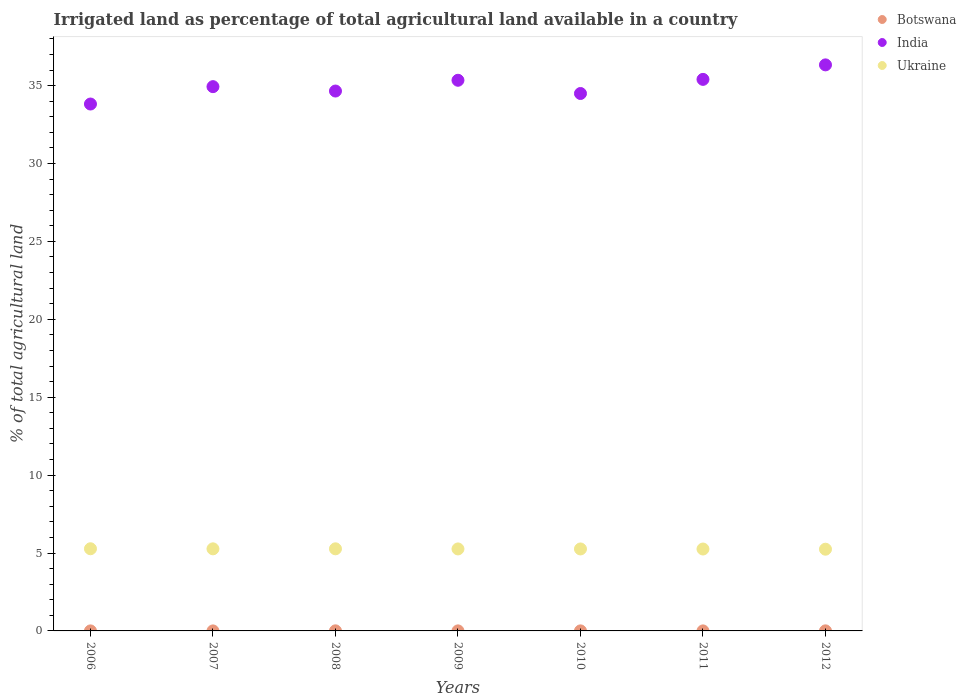How many different coloured dotlines are there?
Offer a terse response. 3. What is the percentage of irrigated land in Botswana in 2011?
Your answer should be compact. 0. Across all years, what is the maximum percentage of irrigated land in India?
Your answer should be compact. 36.33. Across all years, what is the minimum percentage of irrigated land in Ukraine?
Provide a short and direct response. 5.24. What is the total percentage of irrigated land in Botswana in the graph?
Your response must be concise. 0.02. What is the difference between the percentage of irrigated land in Botswana in 2008 and that in 2010?
Your response must be concise. 0. What is the difference between the percentage of irrigated land in Ukraine in 2006 and the percentage of irrigated land in Botswana in 2007?
Provide a succinct answer. 5.27. What is the average percentage of irrigated land in Botswana per year?
Offer a terse response. 0. In the year 2006, what is the difference between the percentage of irrigated land in Ukraine and percentage of irrigated land in Botswana?
Provide a short and direct response. 5.27. What is the ratio of the percentage of irrigated land in India in 2007 to that in 2008?
Offer a terse response. 1.01. Is the percentage of irrigated land in Botswana in 2006 less than that in 2008?
Make the answer very short. Yes. What is the difference between the highest and the second highest percentage of irrigated land in Ukraine?
Your response must be concise. 0. What is the difference between the highest and the lowest percentage of irrigated land in India?
Provide a succinct answer. 2.51. Is the sum of the percentage of irrigated land in Ukraine in 2008 and 2011 greater than the maximum percentage of irrigated land in Botswana across all years?
Give a very brief answer. Yes. Is it the case that in every year, the sum of the percentage of irrigated land in India and percentage of irrigated land in Botswana  is greater than the percentage of irrigated land in Ukraine?
Offer a terse response. Yes. Is the percentage of irrigated land in India strictly less than the percentage of irrigated land in Botswana over the years?
Offer a terse response. No. How many dotlines are there?
Provide a succinct answer. 3. What is the difference between two consecutive major ticks on the Y-axis?
Provide a short and direct response. 5. Are the values on the major ticks of Y-axis written in scientific E-notation?
Keep it short and to the point. No. Where does the legend appear in the graph?
Provide a succinct answer. Top right. How many legend labels are there?
Make the answer very short. 3. What is the title of the graph?
Provide a short and direct response. Irrigated land as percentage of total agricultural land available in a country. Does "Kenya" appear as one of the legend labels in the graph?
Provide a succinct answer. No. What is the label or title of the X-axis?
Provide a succinct answer. Years. What is the label or title of the Y-axis?
Ensure brevity in your answer.  % of total agricultural land. What is the % of total agricultural land of Botswana in 2006?
Your answer should be very brief. 0. What is the % of total agricultural land in India in 2006?
Keep it short and to the point. 33.82. What is the % of total agricultural land of Ukraine in 2006?
Ensure brevity in your answer.  5.27. What is the % of total agricultural land in Botswana in 2007?
Give a very brief answer. 0. What is the % of total agricultural land in India in 2007?
Offer a terse response. 34.93. What is the % of total agricultural land of Ukraine in 2007?
Provide a succinct answer. 5.27. What is the % of total agricultural land in Botswana in 2008?
Keep it short and to the point. 0.01. What is the % of total agricultural land in India in 2008?
Make the answer very short. 34.65. What is the % of total agricultural land of Ukraine in 2008?
Give a very brief answer. 5.27. What is the % of total agricultural land of Botswana in 2009?
Offer a terse response. 0. What is the % of total agricultural land in India in 2009?
Give a very brief answer. 35.34. What is the % of total agricultural land of Ukraine in 2009?
Your response must be concise. 5.26. What is the % of total agricultural land in Botswana in 2010?
Your response must be concise. 0. What is the % of total agricultural land of India in 2010?
Make the answer very short. 34.49. What is the % of total agricultural land of Ukraine in 2010?
Your answer should be compact. 5.26. What is the % of total agricultural land of Botswana in 2011?
Give a very brief answer. 0. What is the % of total agricultural land of India in 2011?
Offer a very short reply. 35.4. What is the % of total agricultural land of Ukraine in 2011?
Offer a very short reply. 5.26. What is the % of total agricultural land of Botswana in 2012?
Give a very brief answer. 0. What is the % of total agricultural land of India in 2012?
Provide a short and direct response. 36.33. What is the % of total agricultural land in Ukraine in 2012?
Keep it short and to the point. 5.24. Across all years, what is the maximum % of total agricultural land in Botswana?
Offer a terse response. 0.01. Across all years, what is the maximum % of total agricultural land in India?
Offer a very short reply. 36.33. Across all years, what is the maximum % of total agricultural land in Ukraine?
Make the answer very short. 5.27. Across all years, what is the minimum % of total agricultural land of Botswana?
Keep it short and to the point. 0. Across all years, what is the minimum % of total agricultural land in India?
Offer a terse response. 33.82. Across all years, what is the minimum % of total agricultural land of Ukraine?
Provide a short and direct response. 5.24. What is the total % of total agricultural land of Botswana in the graph?
Offer a terse response. 0.02. What is the total % of total agricultural land of India in the graph?
Offer a very short reply. 244.96. What is the total % of total agricultural land in Ukraine in the graph?
Your answer should be very brief. 36.84. What is the difference between the % of total agricultural land in Botswana in 2006 and that in 2007?
Ensure brevity in your answer.  0. What is the difference between the % of total agricultural land of India in 2006 and that in 2007?
Provide a short and direct response. -1.12. What is the difference between the % of total agricultural land of Ukraine in 2006 and that in 2007?
Provide a short and direct response. 0.01. What is the difference between the % of total agricultural land of Botswana in 2006 and that in 2008?
Your answer should be compact. -0. What is the difference between the % of total agricultural land in India in 2006 and that in 2008?
Ensure brevity in your answer.  -0.83. What is the difference between the % of total agricultural land of Ukraine in 2006 and that in 2008?
Your answer should be very brief. 0. What is the difference between the % of total agricultural land in Botswana in 2006 and that in 2009?
Give a very brief answer. -0. What is the difference between the % of total agricultural land in India in 2006 and that in 2009?
Keep it short and to the point. -1.53. What is the difference between the % of total agricultural land in Ukraine in 2006 and that in 2009?
Ensure brevity in your answer.  0.01. What is the difference between the % of total agricultural land in Botswana in 2006 and that in 2010?
Your response must be concise. -0. What is the difference between the % of total agricultural land in India in 2006 and that in 2010?
Offer a terse response. -0.68. What is the difference between the % of total agricultural land in Ukraine in 2006 and that in 2010?
Keep it short and to the point. 0.01. What is the difference between the % of total agricultural land in Botswana in 2006 and that in 2011?
Ensure brevity in your answer.  -0. What is the difference between the % of total agricultural land of India in 2006 and that in 2011?
Ensure brevity in your answer.  -1.58. What is the difference between the % of total agricultural land of Ukraine in 2006 and that in 2011?
Offer a very short reply. 0.02. What is the difference between the % of total agricultural land in Botswana in 2006 and that in 2012?
Your answer should be compact. -0. What is the difference between the % of total agricultural land of India in 2006 and that in 2012?
Offer a very short reply. -2.51. What is the difference between the % of total agricultural land in Ukraine in 2006 and that in 2012?
Offer a very short reply. 0.03. What is the difference between the % of total agricultural land of Botswana in 2007 and that in 2008?
Give a very brief answer. -0.01. What is the difference between the % of total agricultural land of India in 2007 and that in 2008?
Give a very brief answer. 0.28. What is the difference between the % of total agricultural land of Ukraine in 2007 and that in 2008?
Your answer should be compact. -0. What is the difference between the % of total agricultural land of Botswana in 2007 and that in 2009?
Your answer should be compact. -0. What is the difference between the % of total agricultural land in India in 2007 and that in 2009?
Keep it short and to the point. -0.41. What is the difference between the % of total agricultural land of Ukraine in 2007 and that in 2009?
Your answer should be very brief. 0.01. What is the difference between the % of total agricultural land of Botswana in 2007 and that in 2010?
Give a very brief answer. -0. What is the difference between the % of total agricultural land of India in 2007 and that in 2010?
Your response must be concise. 0.44. What is the difference between the % of total agricultural land in Ukraine in 2007 and that in 2010?
Give a very brief answer. 0.01. What is the difference between the % of total agricultural land in Botswana in 2007 and that in 2011?
Your answer should be compact. -0. What is the difference between the % of total agricultural land of India in 2007 and that in 2011?
Offer a terse response. -0.47. What is the difference between the % of total agricultural land of Ukraine in 2007 and that in 2011?
Keep it short and to the point. 0.01. What is the difference between the % of total agricultural land of Botswana in 2007 and that in 2012?
Ensure brevity in your answer.  -0. What is the difference between the % of total agricultural land in India in 2007 and that in 2012?
Ensure brevity in your answer.  -1.4. What is the difference between the % of total agricultural land in Ukraine in 2007 and that in 2012?
Make the answer very short. 0.02. What is the difference between the % of total agricultural land of Botswana in 2008 and that in 2009?
Offer a very short reply. 0. What is the difference between the % of total agricultural land in India in 2008 and that in 2009?
Your response must be concise. -0.69. What is the difference between the % of total agricultural land in Ukraine in 2008 and that in 2009?
Give a very brief answer. 0.01. What is the difference between the % of total agricultural land in Botswana in 2008 and that in 2010?
Offer a very short reply. 0. What is the difference between the % of total agricultural land of India in 2008 and that in 2010?
Your answer should be compact. 0.16. What is the difference between the % of total agricultural land in Ukraine in 2008 and that in 2010?
Provide a succinct answer. 0.01. What is the difference between the % of total agricultural land in Botswana in 2008 and that in 2011?
Your answer should be compact. 0. What is the difference between the % of total agricultural land in India in 2008 and that in 2011?
Make the answer very short. -0.75. What is the difference between the % of total agricultural land in Ukraine in 2008 and that in 2011?
Make the answer very short. 0.01. What is the difference between the % of total agricultural land in Botswana in 2008 and that in 2012?
Keep it short and to the point. 0. What is the difference between the % of total agricultural land in India in 2008 and that in 2012?
Offer a very short reply. -1.68. What is the difference between the % of total agricultural land of Ukraine in 2008 and that in 2012?
Your answer should be compact. 0.02. What is the difference between the % of total agricultural land of Botswana in 2009 and that in 2010?
Make the answer very short. -0. What is the difference between the % of total agricultural land of India in 2009 and that in 2010?
Your answer should be very brief. 0.85. What is the difference between the % of total agricultural land in Ukraine in 2009 and that in 2010?
Provide a succinct answer. 0. What is the difference between the % of total agricultural land in Botswana in 2009 and that in 2011?
Your response must be concise. 0. What is the difference between the % of total agricultural land in India in 2009 and that in 2011?
Offer a very short reply. -0.06. What is the difference between the % of total agricultural land of Ukraine in 2009 and that in 2011?
Your response must be concise. 0.01. What is the difference between the % of total agricultural land of Botswana in 2009 and that in 2012?
Ensure brevity in your answer.  -0. What is the difference between the % of total agricultural land of India in 2009 and that in 2012?
Give a very brief answer. -0.99. What is the difference between the % of total agricultural land of Ukraine in 2009 and that in 2012?
Make the answer very short. 0.02. What is the difference between the % of total agricultural land of Botswana in 2010 and that in 2011?
Offer a very short reply. 0. What is the difference between the % of total agricultural land of India in 2010 and that in 2011?
Your answer should be very brief. -0.91. What is the difference between the % of total agricultural land in Ukraine in 2010 and that in 2011?
Offer a very short reply. 0. What is the difference between the % of total agricultural land in Botswana in 2010 and that in 2012?
Offer a terse response. -0. What is the difference between the % of total agricultural land in India in 2010 and that in 2012?
Your response must be concise. -1.84. What is the difference between the % of total agricultural land in Ukraine in 2010 and that in 2012?
Keep it short and to the point. 0.02. What is the difference between the % of total agricultural land in Botswana in 2011 and that in 2012?
Your response must be concise. -0. What is the difference between the % of total agricultural land in India in 2011 and that in 2012?
Offer a terse response. -0.93. What is the difference between the % of total agricultural land in Ukraine in 2011 and that in 2012?
Offer a terse response. 0.01. What is the difference between the % of total agricultural land in Botswana in 2006 and the % of total agricultural land in India in 2007?
Ensure brevity in your answer.  -34.93. What is the difference between the % of total agricultural land in Botswana in 2006 and the % of total agricultural land in Ukraine in 2007?
Ensure brevity in your answer.  -5.27. What is the difference between the % of total agricultural land in India in 2006 and the % of total agricultural land in Ukraine in 2007?
Offer a very short reply. 28.55. What is the difference between the % of total agricultural land in Botswana in 2006 and the % of total agricultural land in India in 2008?
Your answer should be very brief. -34.65. What is the difference between the % of total agricultural land of Botswana in 2006 and the % of total agricultural land of Ukraine in 2008?
Ensure brevity in your answer.  -5.27. What is the difference between the % of total agricultural land of India in 2006 and the % of total agricultural land of Ukraine in 2008?
Your response must be concise. 28.55. What is the difference between the % of total agricultural land in Botswana in 2006 and the % of total agricultural land in India in 2009?
Your answer should be very brief. -35.34. What is the difference between the % of total agricultural land of Botswana in 2006 and the % of total agricultural land of Ukraine in 2009?
Give a very brief answer. -5.26. What is the difference between the % of total agricultural land in India in 2006 and the % of total agricultural land in Ukraine in 2009?
Give a very brief answer. 28.55. What is the difference between the % of total agricultural land in Botswana in 2006 and the % of total agricultural land in India in 2010?
Give a very brief answer. -34.49. What is the difference between the % of total agricultural land in Botswana in 2006 and the % of total agricultural land in Ukraine in 2010?
Your response must be concise. -5.26. What is the difference between the % of total agricultural land in India in 2006 and the % of total agricultural land in Ukraine in 2010?
Your answer should be very brief. 28.56. What is the difference between the % of total agricultural land in Botswana in 2006 and the % of total agricultural land in India in 2011?
Offer a very short reply. -35.4. What is the difference between the % of total agricultural land in Botswana in 2006 and the % of total agricultural land in Ukraine in 2011?
Make the answer very short. -5.26. What is the difference between the % of total agricultural land in India in 2006 and the % of total agricultural land in Ukraine in 2011?
Offer a very short reply. 28.56. What is the difference between the % of total agricultural land in Botswana in 2006 and the % of total agricultural land in India in 2012?
Your answer should be compact. -36.33. What is the difference between the % of total agricultural land in Botswana in 2006 and the % of total agricultural land in Ukraine in 2012?
Your response must be concise. -5.24. What is the difference between the % of total agricultural land of India in 2006 and the % of total agricultural land of Ukraine in 2012?
Offer a very short reply. 28.57. What is the difference between the % of total agricultural land in Botswana in 2007 and the % of total agricultural land in India in 2008?
Provide a succinct answer. -34.65. What is the difference between the % of total agricultural land of Botswana in 2007 and the % of total agricultural land of Ukraine in 2008?
Keep it short and to the point. -5.27. What is the difference between the % of total agricultural land of India in 2007 and the % of total agricultural land of Ukraine in 2008?
Provide a short and direct response. 29.66. What is the difference between the % of total agricultural land of Botswana in 2007 and the % of total agricultural land of India in 2009?
Provide a succinct answer. -35.34. What is the difference between the % of total agricultural land in Botswana in 2007 and the % of total agricultural land in Ukraine in 2009?
Offer a very short reply. -5.26. What is the difference between the % of total agricultural land in India in 2007 and the % of total agricultural land in Ukraine in 2009?
Make the answer very short. 29.67. What is the difference between the % of total agricultural land of Botswana in 2007 and the % of total agricultural land of India in 2010?
Your answer should be compact. -34.49. What is the difference between the % of total agricultural land of Botswana in 2007 and the % of total agricultural land of Ukraine in 2010?
Offer a terse response. -5.26. What is the difference between the % of total agricultural land in India in 2007 and the % of total agricultural land in Ukraine in 2010?
Your answer should be very brief. 29.67. What is the difference between the % of total agricultural land of Botswana in 2007 and the % of total agricultural land of India in 2011?
Offer a terse response. -35.4. What is the difference between the % of total agricultural land of Botswana in 2007 and the % of total agricultural land of Ukraine in 2011?
Your answer should be compact. -5.26. What is the difference between the % of total agricultural land of India in 2007 and the % of total agricultural land of Ukraine in 2011?
Your answer should be compact. 29.68. What is the difference between the % of total agricultural land of Botswana in 2007 and the % of total agricultural land of India in 2012?
Ensure brevity in your answer.  -36.33. What is the difference between the % of total agricultural land in Botswana in 2007 and the % of total agricultural land in Ukraine in 2012?
Keep it short and to the point. -5.24. What is the difference between the % of total agricultural land of India in 2007 and the % of total agricultural land of Ukraine in 2012?
Your answer should be very brief. 29.69. What is the difference between the % of total agricultural land in Botswana in 2008 and the % of total agricultural land in India in 2009?
Make the answer very short. -35.34. What is the difference between the % of total agricultural land of Botswana in 2008 and the % of total agricultural land of Ukraine in 2009?
Provide a short and direct response. -5.26. What is the difference between the % of total agricultural land in India in 2008 and the % of total agricultural land in Ukraine in 2009?
Make the answer very short. 29.39. What is the difference between the % of total agricultural land of Botswana in 2008 and the % of total agricultural land of India in 2010?
Provide a short and direct response. -34.49. What is the difference between the % of total agricultural land of Botswana in 2008 and the % of total agricultural land of Ukraine in 2010?
Offer a very short reply. -5.26. What is the difference between the % of total agricultural land of India in 2008 and the % of total agricultural land of Ukraine in 2010?
Ensure brevity in your answer.  29.39. What is the difference between the % of total agricultural land of Botswana in 2008 and the % of total agricultural land of India in 2011?
Make the answer very short. -35.39. What is the difference between the % of total agricultural land of Botswana in 2008 and the % of total agricultural land of Ukraine in 2011?
Ensure brevity in your answer.  -5.25. What is the difference between the % of total agricultural land of India in 2008 and the % of total agricultural land of Ukraine in 2011?
Provide a succinct answer. 29.39. What is the difference between the % of total agricultural land of Botswana in 2008 and the % of total agricultural land of India in 2012?
Provide a short and direct response. -36.32. What is the difference between the % of total agricultural land in Botswana in 2008 and the % of total agricultural land in Ukraine in 2012?
Provide a short and direct response. -5.24. What is the difference between the % of total agricultural land in India in 2008 and the % of total agricultural land in Ukraine in 2012?
Your answer should be very brief. 29.41. What is the difference between the % of total agricultural land of Botswana in 2009 and the % of total agricultural land of India in 2010?
Your response must be concise. -34.49. What is the difference between the % of total agricultural land of Botswana in 2009 and the % of total agricultural land of Ukraine in 2010?
Your answer should be compact. -5.26. What is the difference between the % of total agricultural land in India in 2009 and the % of total agricultural land in Ukraine in 2010?
Give a very brief answer. 30.08. What is the difference between the % of total agricultural land of Botswana in 2009 and the % of total agricultural land of India in 2011?
Provide a succinct answer. -35.4. What is the difference between the % of total agricultural land of Botswana in 2009 and the % of total agricultural land of Ukraine in 2011?
Give a very brief answer. -5.25. What is the difference between the % of total agricultural land in India in 2009 and the % of total agricultural land in Ukraine in 2011?
Your answer should be compact. 30.09. What is the difference between the % of total agricultural land of Botswana in 2009 and the % of total agricultural land of India in 2012?
Provide a succinct answer. -36.33. What is the difference between the % of total agricultural land of Botswana in 2009 and the % of total agricultural land of Ukraine in 2012?
Keep it short and to the point. -5.24. What is the difference between the % of total agricultural land in India in 2009 and the % of total agricultural land in Ukraine in 2012?
Your answer should be compact. 30.1. What is the difference between the % of total agricultural land in Botswana in 2010 and the % of total agricultural land in India in 2011?
Your answer should be compact. -35.4. What is the difference between the % of total agricultural land of Botswana in 2010 and the % of total agricultural land of Ukraine in 2011?
Give a very brief answer. -5.25. What is the difference between the % of total agricultural land of India in 2010 and the % of total agricultural land of Ukraine in 2011?
Keep it short and to the point. 29.24. What is the difference between the % of total agricultural land of Botswana in 2010 and the % of total agricultural land of India in 2012?
Make the answer very short. -36.33. What is the difference between the % of total agricultural land of Botswana in 2010 and the % of total agricultural land of Ukraine in 2012?
Offer a very short reply. -5.24. What is the difference between the % of total agricultural land of India in 2010 and the % of total agricultural land of Ukraine in 2012?
Your response must be concise. 29.25. What is the difference between the % of total agricultural land in Botswana in 2011 and the % of total agricultural land in India in 2012?
Your answer should be very brief. -36.33. What is the difference between the % of total agricultural land in Botswana in 2011 and the % of total agricultural land in Ukraine in 2012?
Ensure brevity in your answer.  -5.24. What is the difference between the % of total agricultural land in India in 2011 and the % of total agricultural land in Ukraine in 2012?
Your answer should be very brief. 30.15. What is the average % of total agricultural land in Botswana per year?
Make the answer very short. 0. What is the average % of total agricultural land in India per year?
Your answer should be very brief. 34.99. What is the average % of total agricultural land of Ukraine per year?
Ensure brevity in your answer.  5.26. In the year 2006, what is the difference between the % of total agricultural land in Botswana and % of total agricultural land in India?
Keep it short and to the point. -33.82. In the year 2006, what is the difference between the % of total agricultural land in Botswana and % of total agricultural land in Ukraine?
Make the answer very short. -5.27. In the year 2006, what is the difference between the % of total agricultural land of India and % of total agricultural land of Ukraine?
Make the answer very short. 28.54. In the year 2007, what is the difference between the % of total agricultural land of Botswana and % of total agricultural land of India?
Give a very brief answer. -34.93. In the year 2007, what is the difference between the % of total agricultural land in Botswana and % of total agricultural land in Ukraine?
Your answer should be compact. -5.27. In the year 2007, what is the difference between the % of total agricultural land in India and % of total agricultural land in Ukraine?
Offer a very short reply. 29.66. In the year 2008, what is the difference between the % of total agricultural land in Botswana and % of total agricultural land in India?
Ensure brevity in your answer.  -34.64. In the year 2008, what is the difference between the % of total agricultural land in Botswana and % of total agricultural land in Ukraine?
Your answer should be compact. -5.26. In the year 2008, what is the difference between the % of total agricultural land of India and % of total agricultural land of Ukraine?
Provide a short and direct response. 29.38. In the year 2009, what is the difference between the % of total agricultural land of Botswana and % of total agricultural land of India?
Make the answer very short. -35.34. In the year 2009, what is the difference between the % of total agricultural land in Botswana and % of total agricultural land in Ukraine?
Offer a very short reply. -5.26. In the year 2009, what is the difference between the % of total agricultural land in India and % of total agricultural land in Ukraine?
Your response must be concise. 30.08. In the year 2010, what is the difference between the % of total agricultural land in Botswana and % of total agricultural land in India?
Your answer should be compact. -34.49. In the year 2010, what is the difference between the % of total agricultural land of Botswana and % of total agricultural land of Ukraine?
Give a very brief answer. -5.26. In the year 2010, what is the difference between the % of total agricultural land of India and % of total agricultural land of Ukraine?
Ensure brevity in your answer.  29.23. In the year 2011, what is the difference between the % of total agricultural land in Botswana and % of total agricultural land in India?
Ensure brevity in your answer.  -35.4. In the year 2011, what is the difference between the % of total agricultural land of Botswana and % of total agricultural land of Ukraine?
Your answer should be compact. -5.26. In the year 2011, what is the difference between the % of total agricultural land of India and % of total agricultural land of Ukraine?
Keep it short and to the point. 30.14. In the year 2012, what is the difference between the % of total agricultural land of Botswana and % of total agricultural land of India?
Ensure brevity in your answer.  -36.33. In the year 2012, what is the difference between the % of total agricultural land of Botswana and % of total agricultural land of Ukraine?
Provide a short and direct response. -5.24. In the year 2012, what is the difference between the % of total agricultural land in India and % of total agricultural land in Ukraine?
Your answer should be compact. 31.08. What is the ratio of the % of total agricultural land of Botswana in 2006 to that in 2007?
Make the answer very short. 1.43. What is the ratio of the % of total agricultural land of India in 2006 to that in 2007?
Provide a short and direct response. 0.97. What is the ratio of the % of total agricultural land in Ukraine in 2006 to that in 2007?
Ensure brevity in your answer.  1. What is the ratio of the % of total agricultural land in Botswana in 2006 to that in 2008?
Your answer should be very brief. 0.2. What is the ratio of the % of total agricultural land in India in 2006 to that in 2008?
Your response must be concise. 0.98. What is the ratio of the % of total agricultural land in Ukraine in 2006 to that in 2008?
Your answer should be very brief. 1. What is the ratio of the % of total agricultural land in Botswana in 2006 to that in 2009?
Give a very brief answer. 0.46. What is the ratio of the % of total agricultural land of India in 2006 to that in 2009?
Your answer should be compact. 0.96. What is the ratio of the % of total agricultural land of Ukraine in 2006 to that in 2009?
Your response must be concise. 1. What is the ratio of the % of total agricultural land in Botswana in 2006 to that in 2010?
Ensure brevity in your answer.  0.4. What is the ratio of the % of total agricultural land of India in 2006 to that in 2010?
Give a very brief answer. 0.98. What is the ratio of the % of total agricultural land in Ukraine in 2006 to that in 2010?
Your answer should be very brief. 1. What is the ratio of the % of total agricultural land of Botswana in 2006 to that in 2011?
Provide a short and direct response. 0.86. What is the ratio of the % of total agricultural land in India in 2006 to that in 2011?
Offer a terse response. 0.96. What is the ratio of the % of total agricultural land of Botswana in 2006 to that in 2012?
Ensure brevity in your answer.  0.27. What is the ratio of the % of total agricultural land of India in 2006 to that in 2012?
Your answer should be very brief. 0.93. What is the ratio of the % of total agricultural land in Ukraine in 2006 to that in 2012?
Offer a terse response. 1.01. What is the ratio of the % of total agricultural land in Botswana in 2007 to that in 2008?
Give a very brief answer. 0.14. What is the ratio of the % of total agricultural land of India in 2007 to that in 2008?
Offer a very short reply. 1.01. What is the ratio of the % of total agricultural land of Botswana in 2007 to that in 2009?
Provide a short and direct response. 0.32. What is the ratio of the % of total agricultural land of India in 2007 to that in 2009?
Provide a succinct answer. 0.99. What is the ratio of the % of total agricultural land in Ukraine in 2007 to that in 2009?
Provide a succinct answer. 1. What is the ratio of the % of total agricultural land of Botswana in 2007 to that in 2010?
Your answer should be very brief. 0.28. What is the ratio of the % of total agricultural land in India in 2007 to that in 2010?
Offer a terse response. 1.01. What is the ratio of the % of total agricultural land of Botswana in 2007 to that in 2011?
Your answer should be very brief. 0.6. What is the ratio of the % of total agricultural land of Ukraine in 2007 to that in 2011?
Provide a succinct answer. 1. What is the ratio of the % of total agricultural land of Botswana in 2007 to that in 2012?
Provide a succinct answer. 0.19. What is the ratio of the % of total agricultural land in India in 2007 to that in 2012?
Provide a short and direct response. 0.96. What is the ratio of the % of total agricultural land of Ukraine in 2007 to that in 2012?
Keep it short and to the point. 1. What is the ratio of the % of total agricultural land in Botswana in 2008 to that in 2009?
Keep it short and to the point. 2.28. What is the ratio of the % of total agricultural land of India in 2008 to that in 2009?
Your answer should be very brief. 0.98. What is the ratio of the % of total agricultural land of Botswana in 2008 to that in 2010?
Give a very brief answer. 2. What is the ratio of the % of total agricultural land of Ukraine in 2008 to that in 2010?
Your answer should be compact. 1. What is the ratio of the % of total agricultural land in Botswana in 2008 to that in 2011?
Make the answer very short. 4.29. What is the ratio of the % of total agricultural land in India in 2008 to that in 2011?
Your answer should be very brief. 0.98. What is the ratio of the % of total agricultural land in Botswana in 2008 to that in 2012?
Make the answer very short. 1.36. What is the ratio of the % of total agricultural land in India in 2008 to that in 2012?
Your answer should be very brief. 0.95. What is the ratio of the % of total agricultural land in Botswana in 2009 to that in 2010?
Provide a short and direct response. 0.88. What is the ratio of the % of total agricultural land in India in 2009 to that in 2010?
Provide a succinct answer. 1.02. What is the ratio of the % of total agricultural land of Botswana in 2009 to that in 2011?
Give a very brief answer. 1.89. What is the ratio of the % of total agricultural land in India in 2009 to that in 2011?
Your answer should be very brief. 1. What is the ratio of the % of total agricultural land of Ukraine in 2009 to that in 2011?
Provide a short and direct response. 1. What is the ratio of the % of total agricultural land of Botswana in 2009 to that in 2012?
Give a very brief answer. 0.6. What is the ratio of the % of total agricultural land of India in 2009 to that in 2012?
Your answer should be compact. 0.97. What is the ratio of the % of total agricultural land of Ukraine in 2009 to that in 2012?
Your answer should be compact. 1. What is the ratio of the % of total agricultural land of Botswana in 2010 to that in 2011?
Offer a terse response. 2.15. What is the ratio of the % of total agricultural land in India in 2010 to that in 2011?
Provide a succinct answer. 0.97. What is the ratio of the % of total agricultural land of Ukraine in 2010 to that in 2011?
Offer a terse response. 1. What is the ratio of the % of total agricultural land of Botswana in 2010 to that in 2012?
Your answer should be compact. 0.68. What is the ratio of the % of total agricultural land in India in 2010 to that in 2012?
Your answer should be very brief. 0.95. What is the ratio of the % of total agricultural land of Botswana in 2011 to that in 2012?
Offer a very short reply. 0.32. What is the ratio of the % of total agricultural land of India in 2011 to that in 2012?
Offer a very short reply. 0.97. What is the difference between the highest and the second highest % of total agricultural land in Botswana?
Provide a succinct answer. 0. What is the difference between the highest and the second highest % of total agricultural land of India?
Your response must be concise. 0.93. What is the difference between the highest and the second highest % of total agricultural land in Ukraine?
Give a very brief answer. 0. What is the difference between the highest and the lowest % of total agricultural land of Botswana?
Ensure brevity in your answer.  0.01. What is the difference between the highest and the lowest % of total agricultural land of India?
Your answer should be very brief. 2.51. What is the difference between the highest and the lowest % of total agricultural land in Ukraine?
Keep it short and to the point. 0.03. 